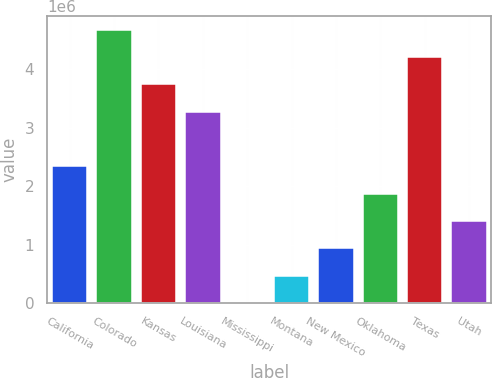Convert chart to OTSL. <chart><loc_0><loc_0><loc_500><loc_500><bar_chart><fcel>California<fcel>Colorado<fcel>Kansas<fcel>Louisiana<fcel>Mississippi<fcel>Montana<fcel>New Mexico<fcel>Oklahoma<fcel>Texas<fcel>Utah<nl><fcel>2.34045e+06<fcel>4.68086e+06<fcel>3.7447e+06<fcel>3.27662e+06<fcel>51<fcel>468132<fcel>936212<fcel>1.87237e+06<fcel>4.21278e+06<fcel>1.40429e+06<nl></chart> 